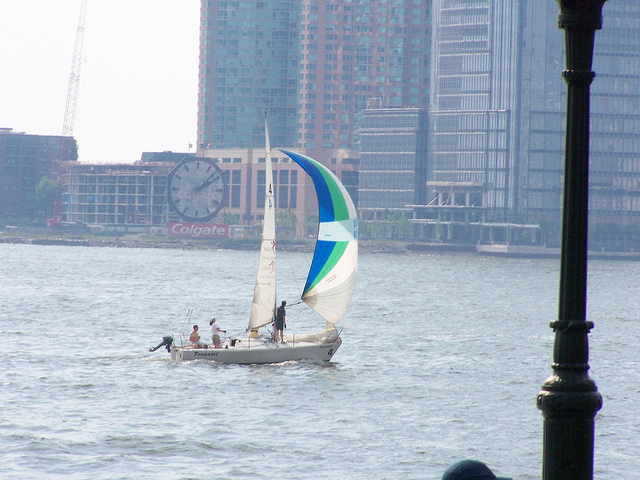What kind of activity are the people engaged in? The people in the image are engaged in sailing. You can identify this by the presence of the sailboat, the sails that are filled with wind, and the activity of the individuals on board, who appear to be managing the sails. 